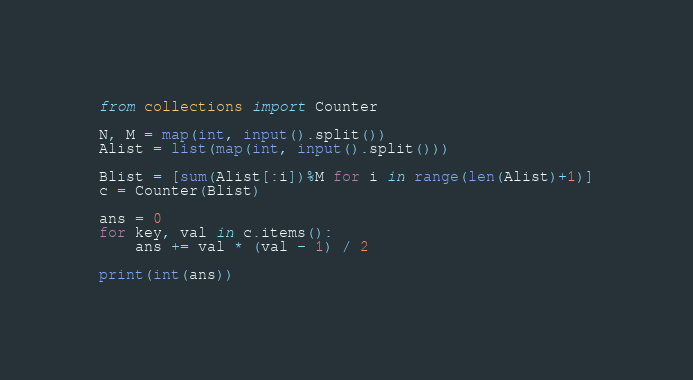<code> <loc_0><loc_0><loc_500><loc_500><_Python_>from collections import Counter

N, M = map(int, input().split())
Alist = list(map(int, input().split()))

Blist = [sum(Alist[:i])%M for i in range(len(Alist)+1)]
c = Counter(Blist)

ans = 0
for key, val in c.items():
    ans += val * (val - 1) / 2

print(int(ans))</code> 